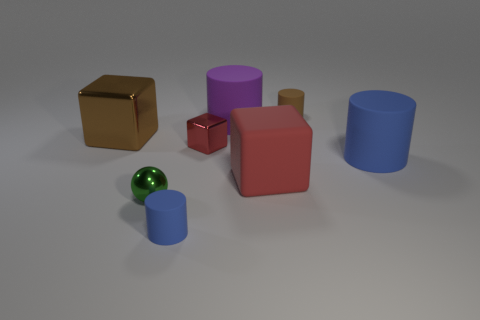How many blue cylinders must be subtracted to get 1 blue cylinders? 1 Subtract all purple cylinders. How many cylinders are left? 3 Subtract all tiny brown rubber cylinders. How many cylinders are left? 3 Subtract 0 yellow cubes. How many objects are left? 8 Subtract all blocks. How many objects are left? 5 Subtract 3 cylinders. How many cylinders are left? 1 Subtract all cyan balls. Subtract all brown blocks. How many balls are left? 1 Subtract all yellow cylinders. How many blue cubes are left? 0 Subtract all tiny blue balls. Subtract all matte cylinders. How many objects are left? 4 Add 5 large blue cylinders. How many large blue cylinders are left? 6 